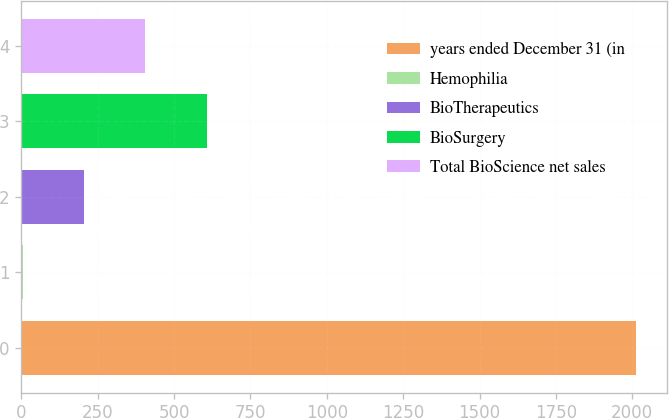Convert chart. <chart><loc_0><loc_0><loc_500><loc_500><bar_chart><fcel>years ended December 31 (in<fcel>Hemophilia<fcel>BioTherapeutics<fcel>BioSurgery<fcel>Total BioScience net sales<nl><fcel>2012<fcel>4<fcel>204.8<fcel>606.4<fcel>405.6<nl></chart> 